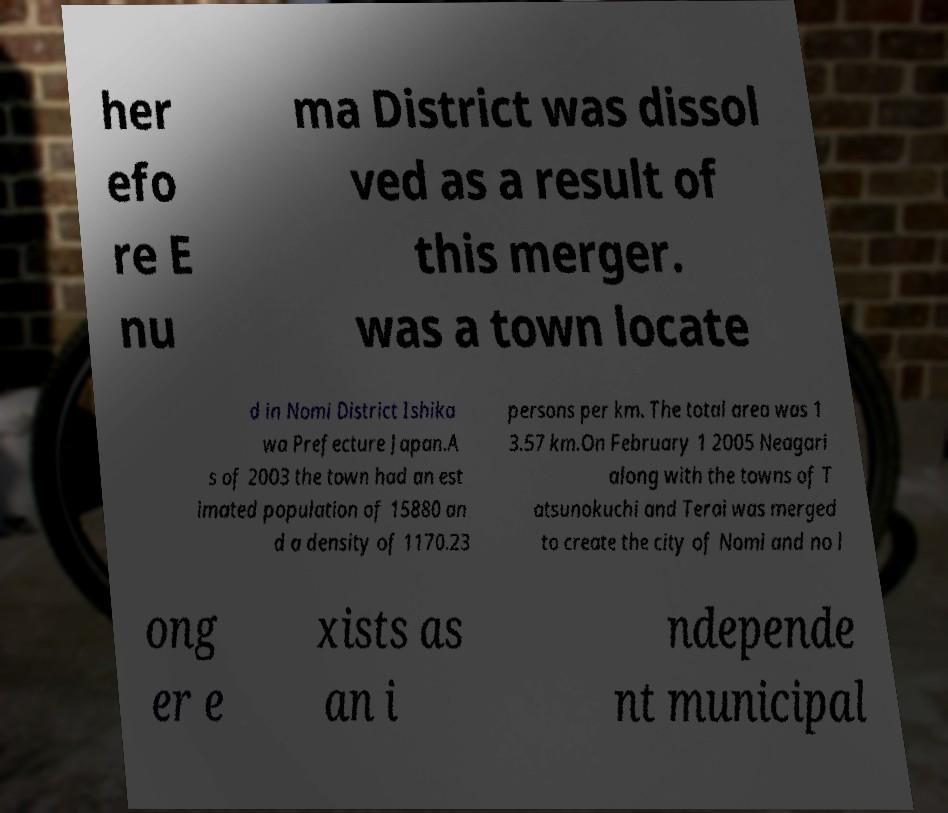Can you read and provide the text displayed in the image?This photo seems to have some interesting text. Can you extract and type it out for me? her efo re E nu ma District was dissol ved as a result of this merger. was a town locate d in Nomi District Ishika wa Prefecture Japan.A s of 2003 the town had an est imated population of 15880 an d a density of 1170.23 persons per km. The total area was 1 3.57 km.On February 1 2005 Neagari along with the towns of T atsunokuchi and Terai was merged to create the city of Nomi and no l ong er e xists as an i ndepende nt municipal 